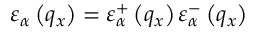<formula> <loc_0><loc_0><loc_500><loc_500>{ { \varepsilon } _ { \alpha } } \left ( { { q } _ { x } } \right ) = \varepsilon _ { \alpha } ^ { + } \left ( { { q } _ { x } } \right ) \varepsilon _ { \alpha } ^ { - } \left ( { { q } _ { x } } \right )</formula> 